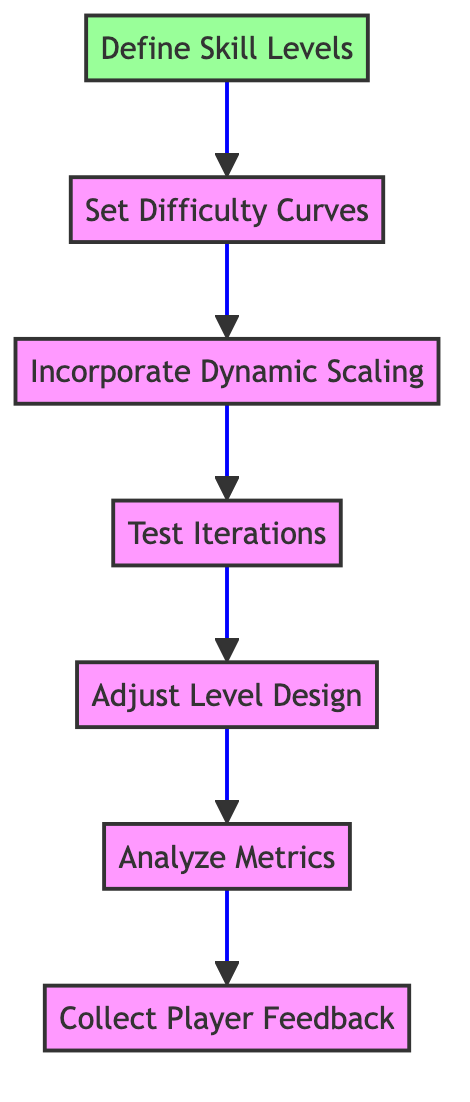What is the first step in the flow chart? The flow chart starts with "Define Skill Levels," which is the first node at the bottom of the diagram.
Answer: Define Skill Levels How many steps are there in total? Counting each node from start to end, there are seven steps in the flow chart.
Answer: Seven What is the last step before "Collect Player Feedback"? The last step before "Collect Player Feedback" is "Analyze Metrics," which directly leads into the feedback collection stage.
Answer: Analyze Metrics Which step directly follows "Set Difficulty Curves"? The step that follows "Set Difficulty Curves" in the flow is "Incorporate Dynamic Scaling," indicating the sequential process in the diagram.
Answer: Incorporate Dynamic Scaling What process is suggested after "Test Iterations"? After "Test Iterations," the next step is "Adjust Level Design," illustrating the flow of adapting the level after testing.
Answer: Adjust Level Design What kind of feedback is collected in the first step? The first step focuses on gathering player feedback to understand pain points and areas of difficulty, which is essential for the next stages.
Answer: Player feedback Which steps involve adjusting difficulty directly? "Adjust Level Design," "Incorporate Dynamic Scaling," and "Set Difficulty Curves" are the three steps that focus directly on adjusting the game's difficulty level.
Answer: Adjust Level Design, Incorporate Dynamic Scaling, Set Difficulty Curves What is the primary goal of analyzing metrics? The primary goal of analyzing metrics is to identify patterns in gameplay data, like player deaths and completion times, which helps inform further adjustments to difficulty.
Answer: Identify patterns 